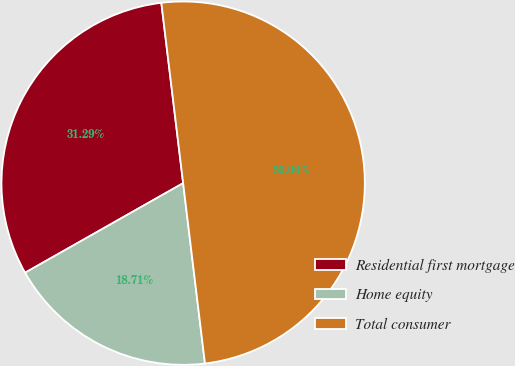Convert chart. <chart><loc_0><loc_0><loc_500><loc_500><pie_chart><fcel>Residential first mortgage<fcel>Home equity<fcel>Total consumer<nl><fcel>31.29%<fcel>18.71%<fcel>50.0%<nl></chart> 